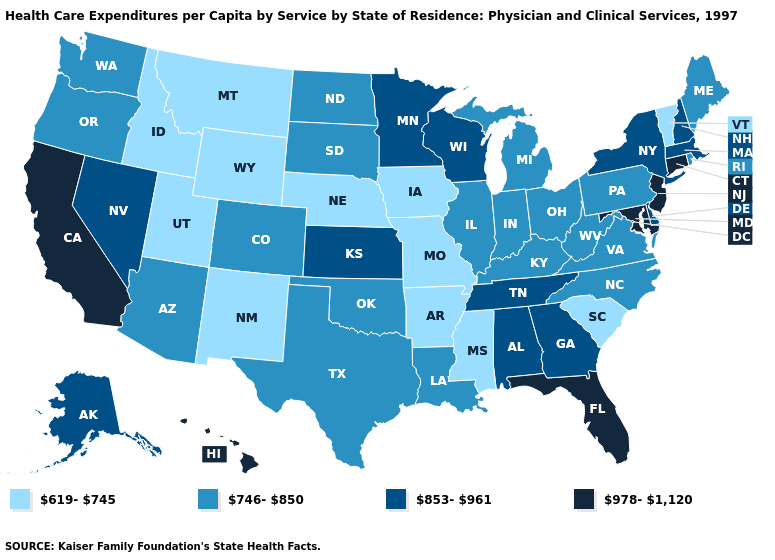Among the states that border New Jersey , does Pennsylvania have the highest value?
Concise answer only. No. What is the value of New Hampshire?
Answer briefly. 853-961. Among the states that border Arkansas , which have the highest value?
Write a very short answer. Tennessee. What is the lowest value in the USA?
Write a very short answer. 619-745. Name the states that have a value in the range 746-850?
Be succinct. Arizona, Colorado, Illinois, Indiana, Kentucky, Louisiana, Maine, Michigan, North Carolina, North Dakota, Ohio, Oklahoma, Oregon, Pennsylvania, Rhode Island, South Dakota, Texas, Virginia, Washington, West Virginia. Among the states that border Idaho , does Nevada have the highest value?
Write a very short answer. Yes. Which states have the highest value in the USA?
Short answer required. California, Connecticut, Florida, Hawaii, Maryland, New Jersey. Name the states that have a value in the range 746-850?
Quick response, please. Arizona, Colorado, Illinois, Indiana, Kentucky, Louisiana, Maine, Michigan, North Carolina, North Dakota, Ohio, Oklahoma, Oregon, Pennsylvania, Rhode Island, South Dakota, Texas, Virginia, Washington, West Virginia. What is the value of Maine?
Be succinct. 746-850. Name the states that have a value in the range 978-1,120?
Be succinct. California, Connecticut, Florida, Hawaii, Maryland, New Jersey. Does Florida have the highest value in the USA?
Answer briefly. Yes. Does Kansas have the same value as Mississippi?
Write a very short answer. No. Name the states that have a value in the range 978-1,120?
Concise answer only. California, Connecticut, Florida, Hawaii, Maryland, New Jersey. Name the states that have a value in the range 853-961?
Give a very brief answer. Alabama, Alaska, Delaware, Georgia, Kansas, Massachusetts, Minnesota, Nevada, New Hampshire, New York, Tennessee, Wisconsin. Does Minnesota have the highest value in the MidWest?
Keep it brief. Yes. 